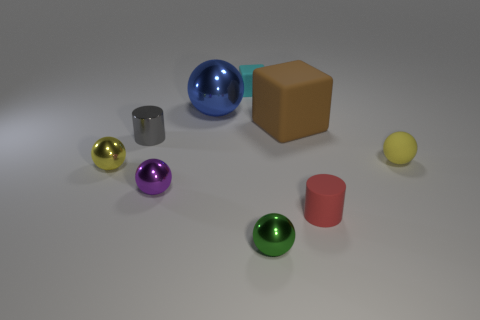Add 1 large blue shiny spheres. How many objects exist? 10 Subtract all gray cylinders. How many cylinders are left? 1 Subtract all yellow rubber balls. How many balls are left? 4 Subtract all cylinders. How many objects are left? 7 Add 4 cyan shiny cylinders. How many cyan shiny cylinders exist? 4 Subtract 1 gray cylinders. How many objects are left? 8 Subtract 1 cylinders. How many cylinders are left? 1 Subtract all red cylinders. Subtract all brown spheres. How many cylinders are left? 1 Subtract all brown cylinders. How many brown balls are left? 0 Subtract all big brown matte objects. Subtract all yellow things. How many objects are left? 6 